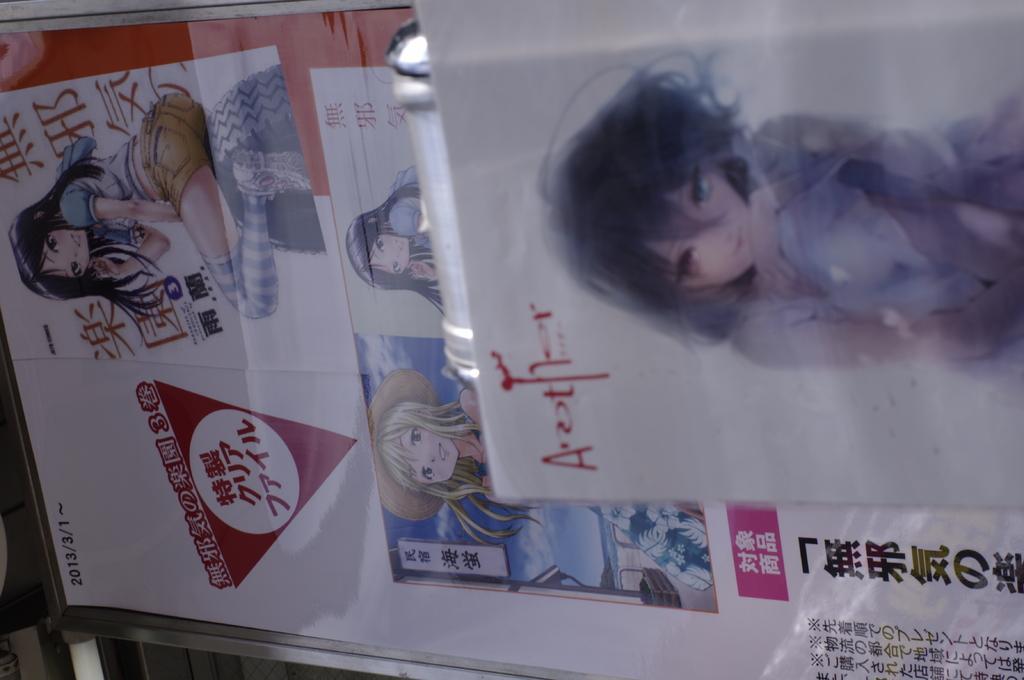Can you describe this image briefly? In this image there are posters on the surface, there are persons and text printed on the posters, there is an object. 